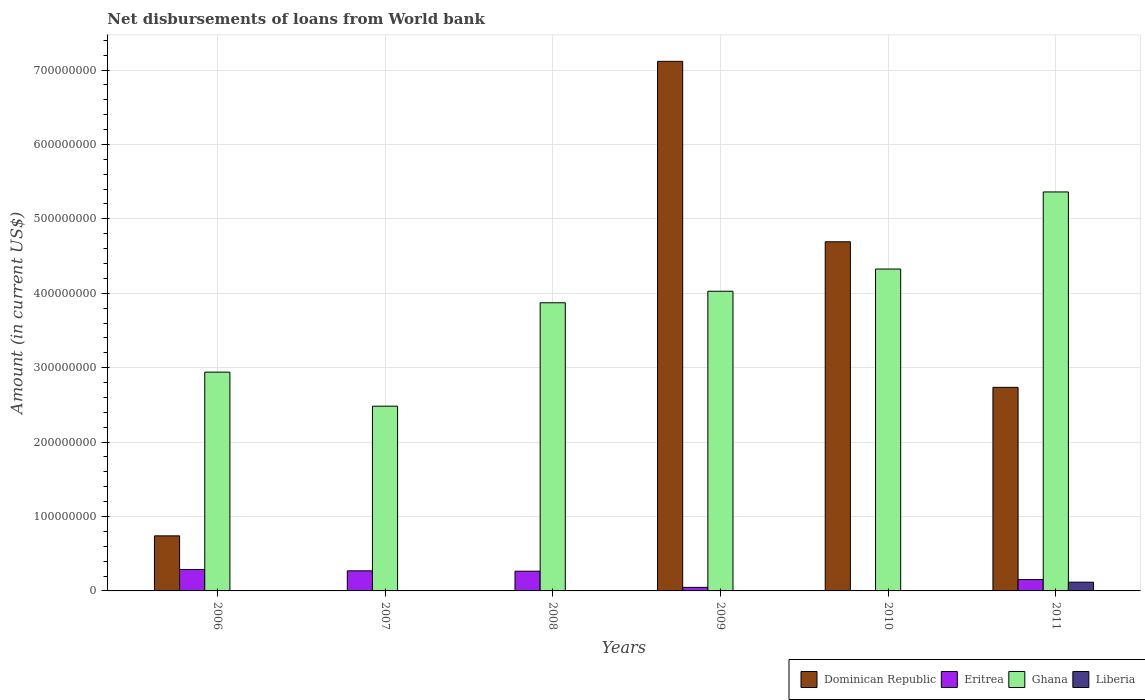What is the amount of loan disbursed from World Bank in Liberia in 2008?
Your answer should be very brief. 0. Across all years, what is the maximum amount of loan disbursed from World Bank in Liberia?
Your response must be concise. 1.17e+07. Across all years, what is the minimum amount of loan disbursed from World Bank in Dominican Republic?
Give a very brief answer. 0. What is the total amount of loan disbursed from World Bank in Liberia in the graph?
Give a very brief answer. 1.17e+07. What is the difference between the amount of loan disbursed from World Bank in Eritrea in 2007 and that in 2009?
Give a very brief answer. 2.22e+07. What is the difference between the amount of loan disbursed from World Bank in Ghana in 2010 and the amount of loan disbursed from World Bank in Dominican Republic in 2009?
Provide a succinct answer. -2.79e+08. What is the average amount of loan disbursed from World Bank in Eritrea per year?
Your answer should be very brief. 1.71e+07. In the year 2010, what is the difference between the amount of loan disbursed from World Bank in Eritrea and amount of loan disbursed from World Bank in Dominican Republic?
Keep it short and to the point. -4.69e+08. What is the ratio of the amount of loan disbursed from World Bank in Eritrea in 2006 to that in 2010?
Offer a very short reply. 266.91. Is the difference between the amount of loan disbursed from World Bank in Eritrea in 2009 and 2011 greater than the difference between the amount of loan disbursed from World Bank in Dominican Republic in 2009 and 2011?
Your answer should be very brief. No. What is the difference between the highest and the second highest amount of loan disbursed from World Bank in Eritrea?
Provide a succinct answer. 1.83e+06. What is the difference between the highest and the lowest amount of loan disbursed from World Bank in Liberia?
Your answer should be very brief. 1.17e+07. In how many years, is the amount of loan disbursed from World Bank in Eritrea greater than the average amount of loan disbursed from World Bank in Eritrea taken over all years?
Ensure brevity in your answer.  3. Is the sum of the amount of loan disbursed from World Bank in Eritrea in 2008 and 2011 greater than the maximum amount of loan disbursed from World Bank in Ghana across all years?
Provide a short and direct response. No. Is it the case that in every year, the sum of the amount of loan disbursed from World Bank in Eritrea and amount of loan disbursed from World Bank in Liberia is greater than the sum of amount of loan disbursed from World Bank in Ghana and amount of loan disbursed from World Bank in Dominican Republic?
Your answer should be very brief. No. Are all the bars in the graph horizontal?
Ensure brevity in your answer.  No. How many years are there in the graph?
Give a very brief answer. 6. Are the values on the major ticks of Y-axis written in scientific E-notation?
Your answer should be very brief. No. Does the graph contain any zero values?
Keep it short and to the point. Yes. Does the graph contain grids?
Provide a succinct answer. Yes. How many legend labels are there?
Make the answer very short. 4. How are the legend labels stacked?
Your response must be concise. Horizontal. What is the title of the graph?
Your answer should be compact. Net disbursements of loans from World bank. Does "Ukraine" appear as one of the legend labels in the graph?
Your answer should be compact. No. What is the label or title of the X-axis?
Give a very brief answer. Years. What is the label or title of the Y-axis?
Keep it short and to the point. Amount (in current US$). What is the Amount (in current US$) of Dominican Republic in 2006?
Ensure brevity in your answer.  7.40e+07. What is the Amount (in current US$) of Eritrea in 2006?
Your answer should be compact. 2.88e+07. What is the Amount (in current US$) in Ghana in 2006?
Ensure brevity in your answer.  2.94e+08. What is the Amount (in current US$) of Eritrea in 2007?
Offer a terse response. 2.70e+07. What is the Amount (in current US$) in Ghana in 2007?
Make the answer very short. 2.48e+08. What is the Amount (in current US$) in Dominican Republic in 2008?
Ensure brevity in your answer.  0. What is the Amount (in current US$) in Eritrea in 2008?
Provide a short and direct response. 2.65e+07. What is the Amount (in current US$) of Ghana in 2008?
Give a very brief answer. 3.87e+08. What is the Amount (in current US$) in Dominican Republic in 2009?
Your answer should be very brief. 7.12e+08. What is the Amount (in current US$) in Eritrea in 2009?
Offer a very short reply. 4.76e+06. What is the Amount (in current US$) of Ghana in 2009?
Offer a terse response. 4.03e+08. What is the Amount (in current US$) of Liberia in 2009?
Ensure brevity in your answer.  0. What is the Amount (in current US$) in Dominican Republic in 2010?
Your answer should be very brief. 4.69e+08. What is the Amount (in current US$) in Eritrea in 2010?
Your answer should be very brief. 1.08e+05. What is the Amount (in current US$) in Ghana in 2010?
Give a very brief answer. 4.33e+08. What is the Amount (in current US$) in Dominican Republic in 2011?
Give a very brief answer. 2.74e+08. What is the Amount (in current US$) of Eritrea in 2011?
Provide a short and direct response. 1.53e+07. What is the Amount (in current US$) of Ghana in 2011?
Your answer should be compact. 5.36e+08. What is the Amount (in current US$) of Liberia in 2011?
Give a very brief answer. 1.17e+07. Across all years, what is the maximum Amount (in current US$) of Dominican Republic?
Your answer should be very brief. 7.12e+08. Across all years, what is the maximum Amount (in current US$) of Eritrea?
Your response must be concise. 2.88e+07. Across all years, what is the maximum Amount (in current US$) in Ghana?
Make the answer very short. 5.36e+08. Across all years, what is the maximum Amount (in current US$) in Liberia?
Your response must be concise. 1.17e+07. Across all years, what is the minimum Amount (in current US$) in Eritrea?
Offer a very short reply. 1.08e+05. Across all years, what is the minimum Amount (in current US$) of Ghana?
Ensure brevity in your answer.  2.48e+08. Across all years, what is the minimum Amount (in current US$) in Liberia?
Provide a short and direct response. 0. What is the total Amount (in current US$) in Dominican Republic in the graph?
Give a very brief answer. 1.53e+09. What is the total Amount (in current US$) of Eritrea in the graph?
Give a very brief answer. 1.02e+08. What is the total Amount (in current US$) in Ghana in the graph?
Provide a succinct answer. 2.30e+09. What is the total Amount (in current US$) of Liberia in the graph?
Your answer should be compact. 1.17e+07. What is the difference between the Amount (in current US$) of Eritrea in 2006 and that in 2007?
Ensure brevity in your answer.  1.83e+06. What is the difference between the Amount (in current US$) in Ghana in 2006 and that in 2007?
Your response must be concise. 4.58e+07. What is the difference between the Amount (in current US$) of Eritrea in 2006 and that in 2008?
Offer a very short reply. 2.32e+06. What is the difference between the Amount (in current US$) of Ghana in 2006 and that in 2008?
Keep it short and to the point. -9.32e+07. What is the difference between the Amount (in current US$) in Dominican Republic in 2006 and that in 2009?
Give a very brief answer. -6.38e+08. What is the difference between the Amount (in current US$) of Eritrea in 2006 and that in 2009?
Your answer should be compact. 2.41e+07. What is the difference between the Amount (in current US$) in Ghana in 2006 and that in 2009?
Keep it short and to the point. -1.09e+08. What is the difference between the Amount (in current US$) in Dominican Republic in 2006 and that in 2010?
Your answer should be very brief. -3.95e+08. What is the difference between the Amount (in current US$) in Eritrea in 2006 and that in 2010?
Keep it short and to the point. 2.87e+07. What is the difference between the Amount (in current US$) in Ghana in 2006 and that in 2010?
Your response must be concise. -1.39e+08. What is the difference between the Amount (in current US$) of Dominican Republic in 2006 and that in 2011?
Provide a succinct answer. -2.00e+08. What is the difference between the Amount (in current US$) of Eritrea in 2006 and that in 2011?
Offer a terse response. 1.35e+07. What is the difference between the Amount (in current US$) of Ghana in 2006 and that in 2011?
Offer a terse response. -2.42e+08. What is the difference between the Amount (in current US$) in Eritrea in 2007 and that in 2008?
Provide a succinct answer. 4.93e+05. What is the difference between the Amount (in current US$) in Ghana in 2007 and that in 2008?
Provide a short and direct response. -1.39e+08. What is the difference between the Amount (in current US$) of Eritrea in 2007 and that in 2009?
Your answer should be very brief. 2.22e+07. What is the difference between the Amount (in current US$) of Ghana in 2007 and that in 2009?
Your response must be concise. -1.54e+08. What is the difference between the Amount (in current US$) of Eritrea in 2007 and that in 2010?
Provide a short and direct response. 2.69e+07. What is the difference between the Amount (in current US$) in Ghana in 2007 and that in 2010?
Your answer should be compact. -1.84e+08. What is the difference between the Amount (in current US$) in Eritrea in 2007 and that in 2011?
Make the answer very short. 1.17e+07. What is the difference between the Amount (in current US$) of Ghana in 2007 and that in 2011?
Your response must be concise. -2.88e+08. What is the difference between the Amount (in current US$) in Eritrea in 2008 and that in 2009?
Provide a succinct answer. 2.17e+07. What is the difference between the Amount (in current US$) in Ghana in 2008 and that in 2009?
Provide a short and direct response. -1.55e+07. What is the difference between the Amount (in current US$) in Eritrea in 2008 and that in 2010?
Your answer should be compact. 2.64e+07. What is the difference between the Amount (in current US$) in Ghana in 2008 and that in 2010?
Ensure brevity in your answer.  -4.53e+07. What is the difference between the Amount (in current US$) in Eritrea in 2008 and that in 2011?
Your response must be concise. 1.12e+07. What is the difference between the Amount (in current US$) in Ghana in 2008 and that in 2011?
Ensure brevity in your answer.  -1.49e+08. What is the difference between the Amount (in current US$) of Dominican Republic in 2009 and that in 2010?
Provide a succinct answer. 2.42e+08. What is the difference between the Amount (in current US$) of Eritrea in 2009 and that in 2010?
Your response must be concise. 4.66e+06. What is the difference between the Amount (in current US$) in Ghana in 2009 and that in 2010?
Your response must be concise. -2.98e+07. What is the difference between the Amount (in current US$) in Dominican Republic in 2009 and that in 2011?
Provide a short and direct response. 4.38e+08. What is the difference between the Amount (in current US$) in Eritrea in 2009 and that in 2011?
Your response must be concise. -1.05e+07. What is the difference between the Amount (in current US$) of Ghana in 2009 and that in 2011?
Keep it short and to the point. -1.33e+08. What is the difference between the Amount (in current US$) of Dominican Republic in 2010 and that in 2011?
Ensure brevity in your answer.  1.96e+08. What is the difference between the Amount (in current US$) in Eritrea in 2010 and that in 2011?
Provide a short and direct response. -1.52e+07. What is the difference between the Amount (in current US$) of Ghana in 2010 and that in 2011?
Provide a succinct answer. -1.04e+08. What is the difference between the Amount (in current US$) in Dominican Republic in 2006 and the Amount (in current US$) in Eritrea in 2007?
Keep it short and to the point. 4.70e+07. What is the difference between the Amount (in current US$) of Dominican Republic in 2006 and the Amount (in current US$) of Ghana in 2007?
Your response must be concise. -1.74e+08. What is the difference between the Amount (in current US$) of Eritrea in 2006 and the Amount (in current US$) of Ghana in 2007?
Make the answer very short. -2.19e+08. What is the difference between the Amount (in current US$) of Dominican Republic in 2006 and the Amount (in current US$) of Eritrea in 2008?
Keep it short and to the point. 4.75e+07. What is the difference between the Amount (in current US$) of Dominican Republic in 2006 and the Amount (in current US$) of Ghana in 2008?
Give a very brief answer. -3.13e+08. What is the difference between the Amount (in current US$) of Eritrea in 2006 and the Amount (in current US$) of Ghana in 2008?
Offer a very short reply. -3.58e+08. What is the difference between the Amount (in current US$) of Dominican Republic in 2006 and the Amount (in current US$) of Eritrea in 2009?
Make the answer very short. 6.92e+07. What is the difference between the Amount (in current US$) of Dominican Republic in 2006 and the Amount (in current US$) of Ghana in 2009?
Make the answer very short. -3.29e+08. What is the difference between the Amount (in current US$) in Eritrea in 2006 and the Amount (in current US$) in Ghana in 2009?
Provide a short and direct response. -3.74e+08. What is the difference between the Amount (in current US$) in Dominican Republic in 2006 and the Amount (in current US$) in Eritrea in 2010?
Ensure brevity in your answer.  7.39e+07. What is the difference between the Amount (in current US$) of Dominican Republic in 2006 and the Amount (in current US$) of Ghana in 2010?
Provide a short and direct response. -3.59e+08. What is the difference between the Amount (in current US$) of Eritrea in 2006 and the Amount (in current US$) of Ghana in 2010?
Offer a very short reply. -4.04e+08. What is the difference between the Amount (in current US$) of Dominican Republic in 2006 and the Amount (in current US$) of Eritrea in 2011?
Your answer should be compact. 5.87e+07. What is the difference between the Amount (in current US$) in Dominican Republic in 2006 and the Amount (in current US$) in Ghana in 2011?
Your answer should be compact. -4.62e+08. What is the difference between the Amount (in current US$) of Dominican Republic in 2006 and the Amount (in current US$) of Liberia in 2011?
Provide a succinct answer. 6.22e+07. What is the difference between the Amount (in current US$) in Eritrea in 2006 and the Amount (in current US$) in Ghana in 2011?
Keep it short and to the point. -5.07e+08. What is the difference between the Amount (in current US$) of Eritrea in 2006 and the Amount (in current US$) of Liberia in 2011?
Your answer should be very brief. 1.71e+07. What is the difference between the Amount (in current US$) in Ghana in 2006 and the Amount (in current US$) in Liberia in 2011?
Keep it short and to the point. 2.82e+08. What is the difference between the Amount (in current US$) in Eritrea in 2007 and the Amount (in current US$) in Ghana in 2008?
Offer a very short reply. -3.60e+08. What is the difference between the Amount (in current US$) of Eritrea in 2007 and the Amount (in current US$) of Ghana in 2009?
Provide a short and direct response. -3.76e+08. What is the difference between the Amount (in current US$) of Eritrea in 2007 and the Amount (in current US$) of Ghana in 2010?
Give a very brief answer. -4.06e+08. What is the difference between the Amount (in current US$) of Eritrea in 2007 and the Amount (in current US$) of Ghana in 2011?
Your answer should be compact. -5.09e+08. What is the difference between the Amount (in current US$) in Eritrea in 2007 and the Amount (in current US$) in Liberia in 2011?
Your answer should be very brief. 1.52e+07. What is the difference between the Amount (in current US$) in Ghana in 2007 and the Amount (in current US$) in Liberia in 2011?
Give a very brief answer. 2.37e+08. What is the difference between the Amount (in current US$) in Eritrea in 2008 and the Amount (in current US$) in Ghana in 2009?
Your answer should be compact. -3.76e+08. What is the difference between the Amount (in current US$) of Eritrea in 2008 and the Amount (in current US$) of Ghana in 2010?
Make the answer very short. -4.06e+08. What is the difference between the Amount (in current US$) in Eritrea in 2008 and the Amount (in current US$) in Ghana in 2011?
Make the answer very short. -5.10e+08. What is the difference between the Amount (in current US$) in Eritrea in 2008 and the Amount (in current US$) in Liberia in 2011?
Provide a short and direct response. 1.48e+07. What is the difference between the Amount (in current US$) in Ghana in 2008 and the Amount (in current US$) in Liberia in 2011?
Your answer should be very brief. 3.75e+08. What is the difference between the Amount (in current US$) in Dominican Republic in 2009 and the Amount (in current US$) in Eritrea in 2010?
Your answer should be compact. 7.12e+08. What is the difference between the Amount (in current US$) in Dominican Republic in 2009 and the Amount (in current US$) in Ghana in 2010?
Ensure brevity in your answer.  2.79e+08. What is the difference between the Amount (in current US$) of Eritrea in 2009 and the Amount (in current US$) of Ghana in 2010?
Ensure brevity in your answer.  -4.28e+08. What is the difference between the Amount (in current US$) of Dominican Republic in 2009 and the Amount (in current US$) of Eritrea in 2011?
Offer a very short reply. 6.96e+08. What is the difference between the Amount (in current US$) of Dominican Republic in 2009 and the Amount (in current US$) of Ghana in 2011?
Your answer should be very brief. 1.75e+08. What is the difference between the Amount (in current US$) in Dominican Republic in 2009 and the Amount (in current US$) in Liberia in 2011?
Offer a very short reply. 7.00e+08. What is the difference between the Amount (in current US$) in Eritrea in 2009 and the Amount (in current US$) in Ghana in 2011?
Provide a short and direct response. -5.31e+08. What is the difference between the Amount (in current US$) in Eritrea in 2009 and the Amount (in current US$) in Liberia in 2011?
Your answer should be compact. -6.98e+06. What is the difference between the Amount (in current US$) of Ghana in 2009 and the Amount (in current US$) of Liberia in 2011?
Offer a terse response. 3.91e+08. What is the difference between the Amount (in current US$) of Dominican Republic in 2010 and the Amount (in current US$) of Eritrea in 2011?
Ensure brevity in your answer.  4.54e+08. What is the difference between the Amount (in current US$) of Dominican Republic in 2010 and the Amount (in current US$) of Ghana in 2011?
Provide a succinct answer. -6.70e+07. What is the difference between the Amount (in current US$) of Dominican Republic in 2010 and the Amount (in current US$) of Liberia in 2011?
Provide a short and direct response. 4.57e+08. What is the difference between the Amount (in current US$) of Eritrea in 2010 and the Amount (in current US$) of Ghana in 2011?
Ensure brevity in your answer.  -5.36e+08. What is the difference between the Amount (in current US$) of Eritrea in 2010 and the Amount (in current US$) of Liberia in 2011?
Your answer should be compact. -1.16e+07. What is the difference between the Amount (in current US$) in Ghana in 2010 and the Amount (in current US$) in Liberia in 2011?
Offer a terse response. 4.21e+08. What is the average Amount (in current US$) of Dominican Republic per year?
Your answer should be compact. 2.55e+08. What is the average Amount (in current US$) in Eritrea per year?
Your answer should be very brief. 1.71e+07. What is the average Amount (in current US$) in Ghana per year?
Keep it short and to the point. 3.83e+08. What is the average Amount (in current US$) in Liberia per year?
Keep it short and to the point. 1.96e+06. In the year 2006, what is the difference between the Amount (in current US$) in Dominican Republic and Amount (in current US$) in Eritrea?
Ensure brevity in your answer.  4.52e+07. In the year 2006, what is the difference between the Amount (in current US$) in Dominican Republic and Amount (in current US$) in Ghana?
Give a very brief answer. -2.20e+08. In the year 2006, what is the difference between the Amount (in current US$) of Eritrea and Amount (in current US$) of Ghana?
Your answer should be compact. -2.65e+08. In the year 2007, what is the difference between the Amount (in current US$) of Eritrea and Amount (in current US$) of Ghana?
Your response must be concise. -2.21e+08. In the year 2008, what is the difference between the Amount (in current US$) in Eritrea and Amount (in current US$) in Ghana?
Ensure brevity in your answer.  -3.61e+08. In the year 2009, what is the difference between the Amount (in current US$) in Dominican Republic and Amount (in current US$) in Eritrea?
Offer a terse response. 7.07e+08. In the year 2009, what is the difference between the Amount (in current US$) in Dominican Republic and Amount (in current US$) in Ghana?
Your response must be concise. 3.09e+08. In the year 2009, what is the difference between the Amount (in current US$) in Eritrea and Amount (in current US$) in Ghana?
Ensure brevity in your answer.  -3.98e+08. In the year 2010, what is the difference between the Amount (in current US$) in Dominican Republic and Amount (in current US$) in Eritrea?
Ensure brevity in your answer.  4.69e+08. In the year 2010, what is the difference between the Amount (in current US$) in Dominican Republic and Amount (in current US$) in Ghana?
Your answer should be very brief. 3.66e+07. In the year 2010, what is the difference between the Amount (in current US$) of Eritrea and Amount (in current US$) of Ghana?
Provide a succinct answer. -4.32e+08. In the year 2011, what is the difference between the Amount (in current US$) of Dominican Republic and Amount (in current US$) of Eritrea?
Your answer should be compact. 2.58e+08. In the year 2011, what is the difference between the Amount (in current US$) in Dominican Republic and Amount (in current US$) in Ghana?
Offer a very short reply. -2.63e+08. In the year 2011, what is the difference between the Amount (in current US$) in Dominican Republic and Amount (in current US$) in Liberia?
Your answer should be compact. 2.62e+08. In the year 2011, what is the difference between the Amount (in current US$) in Eritrea and Amount (in current US$) in Ghana?
Give a very brief answer. -5.21e+08. In the year 2011, what is the difference between the Amount (in current US$) in Eritrea and Amount (in current US$) in Liberia?
Make the answer very short. 3.53e+06. In the year 2011, what is the difference between the Amount (in current US$) in Ghana and Amount (in current US$) in Liberia?
Provide a short and direct response. 5.24e+08. What is the ratio of the Amount (in current US$) in Eritrea in 2006 to that in 2007?
Give a very brief answer. 1.07. What is the ratio of the Amount (in current US$) in Ghana in 2006 to that in 2007?
Make the answer very short. 1.18. What is the ratio of the Amount (in current US$) in Eritrea in 2006 to that in 2008?
Your answer should be compact. 1.09. What is the ratio of the Amount (in current US$) in Ghana in 2006 to that in 2008?
Provide a short and direct response. 0.76. What is the ratio of the Amount (in current US$) in Dominican Republic in 2006 to that in 2009?
Keep it short and to the point. 0.1. What is the ratio of the Amount (in current US$) in Eritrea in 2006 to that in 2009?
Offer a terse response. 6.05. What is the ratio of the Amount (in current US$) in Ghana in 2006 to that in 2009?
Give a very brief answer. 0.73. What is the ratio of the Amount (in current US$) of Dominican Republic in 2006 to that in 2010?
Your response must be concise. 0.16. What is the ratio of the Amount (in current US$) of Eritrea in 2006 to that in 2010?
Your answer should be compact. 266.91. What is the ratio of the Amount (in current US$) of Ghana in 2006 to that in 2010?
Ensure brevity in your answer.  0.68. What is the ratio of the Amount (in current US$) of Dominican Republic in 2006 to that in 2011?
Provide a succinct answer. 0.27. What is the ratio of the Amount (in current US$) in Eritrea in 2006 to that in 2011?
Make the answer very short. 1.89. What is the ratio of the Amount (in current US$) of Ghana in 2006 to that in 2011?
Your answer should be very brief. 0.55. What is the ratio of the Amount (in current US$) in Eritrea in 2007 to that in 2008?
Offer a terse response. 1.02. What is the ratio of the Amount (in current US$) of Ghana in 2007 to that in 2008?
Your response must be concise. 0.64. What is the ratio of the Amount (in current US$) of Eritrea in 2007 to that in 2009?
Your answer should be very brief. 5.67. What is the ratio of the Amount (in current US$) in Ghana in 2007 to that in 2009?
Your answer should be compact. 0.62. What is the ratio of the Amount (in current US$) of Eritrea in 2007 to that in 2010?
Keep it short and to the point. 249.96. What is the ratio of the Amount (in current US$) in Ghana in 2007 to that in 2010?
Ensure brevity in your answer.  0.57. What is the ratio of the Amount (in current US$) in Eritrea in 2007 to that in 2011?
Make the answer very short. 1.77. What is the ratio of the Amount (in current US$) in Ghana in 2007 to that in 2011?
Your answer should be very brief. 0.46. What is the ratio of the Amount (in current US$) of Eritrea in 2008 to that in 2009?
Keep it short and to the point. 5.56. What is the ratio of the Amount (in current US$) of Ghana in 2008 to that in 2009?
Make the answer very short. 0.96. What is the ratio of the Amount (in current US$) of Eritrea in 2008 to that in 2010?
Ensure brevity in your answer.  245.4. What is the ratio of the Amount (in current US$) of Ghana in 2008 to that in 2010?
Give a very brief answer. 0.9. What is the ratio of the Amount (in current US$) in Eritrea in 2008 to that in 2011?
Keep it short and to the point. 1.73. What is the ratio of the Amount (in current US$) of Ghana in 2008 to that in 2011?
Make the answer very short. 0.72. What is the ratio of the Amount (in current US$) in Dominican Republic in 2009 to that in 2010?
Your response must be concise. 1.52. What is the ratio of the Amount (in current US$) of Eritrea in 2009 to that in 2010?
Your response must be concise. 44.1. What is the ratio of the Amount (in current US$) in Ghana in 2009 to that in 2010?
Offer a terse response. 0.93. What is the ratio of the Amount (in current US$) in Dominican Republic in 2009 to that in 2011?
Give a very brief answer. 2.6. What is the ratio of the Amount (in current US$) in Eritrea in 2009 to that in 2011?
Give a very brief answer. 0.31. What is the ratio of the Amount (in current US$) in Ghana in 2009 to that in 2011?
Keep it short and to the point. 0.75. What is the ratio of the Amount (in current US$) in Dominican Republic in 2010 to that in 2011?
Give a very brief answer. 1.71. What is the ratio of the Amount (in current US$) of Eritrea in 2010 to that in 2011?
Offer a very short reply. 0.01. What is the ratio of the Amount (in current US$) in Ghana in 2010 to that in 2011?
Your response must be concise. 0.81. What is the difference between the highest and the second highest Amount (in current US$) in Dominican Republic?
Make the answer very short. 2.42e+08. What is the difference between the highest and the second highest Amount (in current US$) in Eritrea?
Ensure brevity in your answer.  1.83e+06. What is the difference between the highest and the second highest Amount (in current US$) of Ghana?
Offer a terse response. 1.04e+08. What is the difference between the highest and the lowest Amount (in current US$) of Dominican Republic?
Provide a succinct answer. 7.12e+08. What is the difference between the highest and the lowest Amount (in current US$) in Eritrea?
Make the answer very short. 2.87e+07. What is the difference between the highest and the lowest Amount (in current US$) of Ghana?
Your answer should be compact. 2.88e+08. What is the difference between the highest and the lowest Amount (in current US$) in Liberia?
Provide a succinct answer. 1.17e+07. 